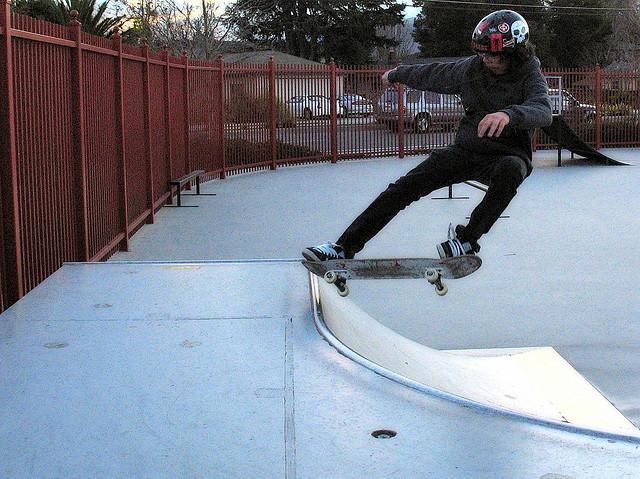What color is the fence?
Keep it brief. Red. How many motor vehicles are pictured?
Be succinct. 4. Is there a skull on the helmet?
Give a very brief answer. Yes. 